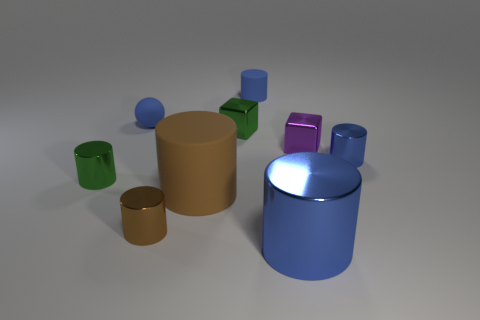How many metallic objects are either tiny purple cylinders or tiny spheres? In the image, there is one tiny purple cylinder and one tiny sphere, totaling two metallic objects that fit the criteria. 